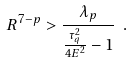Convert formula to latex. <formula><loc_0><loc_0><loc_500><loc_500>R ^ { 7 - p } > \frac { \lambda _ { p } } { \frac { \tau _ { q } ^ { 2 } } { 4 E ^ { 2 } } - 1 } \ .</formula> 